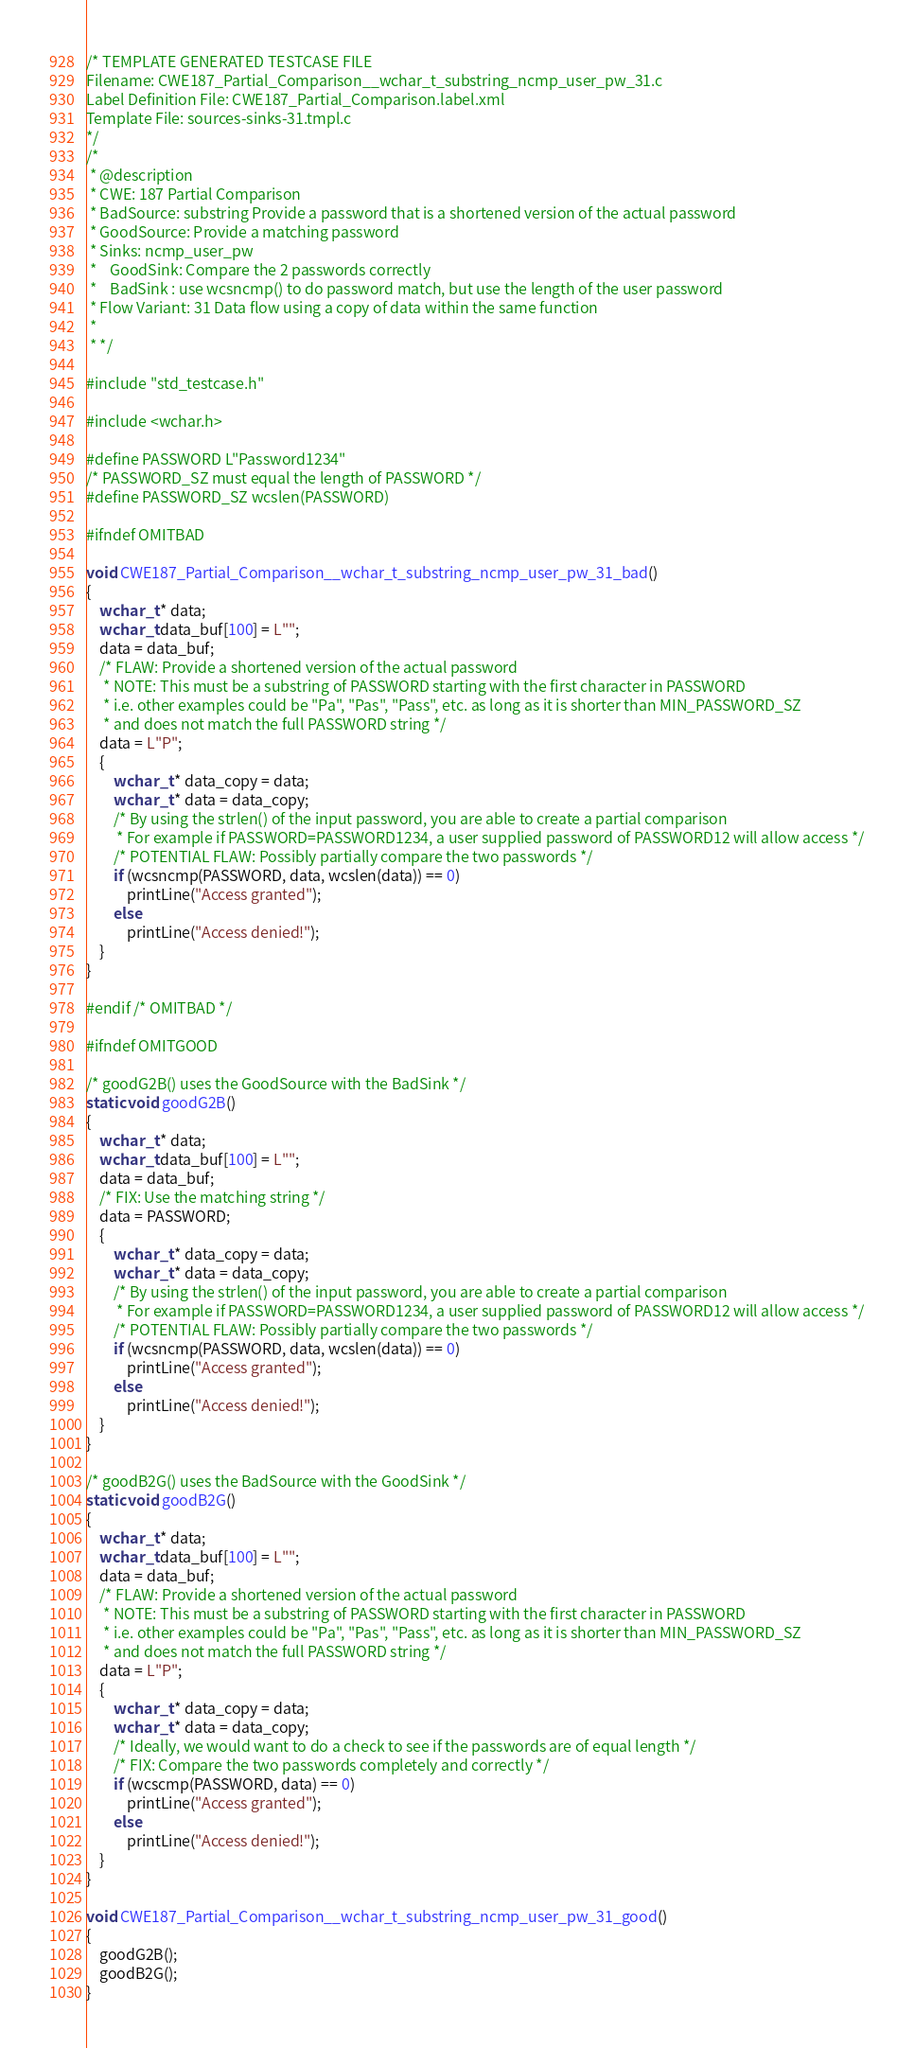Convert code to text. <code><loc_0><loc_0><loc_500><loc_500><_C_>/* TEMPLATE GENERATED TESTCASE FILE
Filename: CWE187_Partial_Comparison__wchar_t_substring_ncmp_user_pw_31.c
Label Definition File: CWE187_Partial_Comparison.label.xml
Template File: sources-sinks-31.tmpl.c
*/
/*
 * @description
 * CWE: 187 Partial Comparison
 * BadSource: substring Provide a password that is a shortened version of the actual password
 * GoodSource: Provide a matching password
 * Sinks: ncmp_user_pw
 *    GoodSink: Compare the 2 passwords correctly
 *    BadSink : use wcsncmp() to do password match, but use the length of the user password
 * Flow Variant: 31 Data flow using a copy of data within the same function
 *
 * */

#include "std_testcase.h"

#include <wchar.h>

#define PASSWORD L"Password1234"
/* PASSWORD_SZ must equal the length of PASSWORD */
#define PASSWORD_SZ wcslen(PASSWORD)

#ifndef OMITBAD

void CWE187_Partial_Comparison__wchar_t_substring_ncmp_user_pw_31_bad()
{
    wchar_t * data;
    wchar_t data_buf[100] = L"";
    data = data_buf;
    /* FLAW: Provide a shortened version of the actual password
     * NOTE: This must be a substring of PASSWORD starting with the first character in PASSWORD
     * i.e. other examples could be "Pa", "Pas", "Pass", etc. as long as it is shorter than MIN_PASSWORD_SZ
     * and does not match the full PASSWORD string */
    data = L"P";
    {
        wchar_t * data_copy = data;
        wchar_t * data = data_copy;
        /* By using the strlen() of the input password, you are able to create a partial comparison
         * For example if PASSWORD=PASSWORD1234, a user supplied password of PASSWORD12 will allow access */
        /* POTENTIAL FLAW: Possibly partially compare the two passwords */
        if (wcsncmp(PASSWORD, data, wcslen(data)) == 0)
            printLine("Access granted");
        else
            printLine("Access denied!");
    }
}

#endif /* OMITBAD */

#ifndef OMITGOOD

/* goodG2B() uses the GoodSource with the BadSink */
static void goodG2B()
{
    wchar_t * data;
    wchar_t data_buf[100] = L"";
    data = data_buf;
    /* FIX: Use the matching string */
    data = PASSWORD;
    {
        wchar_t * data_copy = data;
        wchar_t * data = data_copy;
        /* By using the strlen() of the input password, you are able to create a partial comparison
         * For example if PASSWORD=PASSWORD1234, a user supplied password of PASSWORD12 will allow access */
        /* POTENTIAL FLAW: Possibly partially compare the two passwords */
        if (wcsncmp(PASSWORD, data, wcslen(data)) == 0)
            printLine("Access granted");
        else
            printLine("Access denied!");
    }
}

/* goodB2G() uses the BadSource with the GoodSink */
static void goodB2G()
{
    wchar_t * data;
    wchar_t data_buf[100] = L"";
    data = data_buf;
    /* FLAW: Provide a shortened version of the actual password
     * NOTE: This must be a substring of PASSWORD starting with the first character in PASSWORD
     * i.e. other examples could be "Pa", "Pas", "Pass", etc. as long as it is shorter than MIN_PASSWORD_SZ
     * and does not match the full PASSWORD string */
    data = L"P";
    {
        wchar_t * data_copy = data;
        wchar_t * data = data_copy;
        /* Ideally, we would want to do a check to see if the passwords are of equal length */
        /* FIX: Compare the two passwords completely and correctly */
        if (wcscmp(PASSWORD, data) == 0)
            printLine("Access granted");
        else
            printLine("Access denied!");
    }
}

void CWE187_Partial_Comparison__wchar_t_substring_ncmp_user_pw_31_good()
{
    goodG2B();
    goodB2G();
}
</code> 